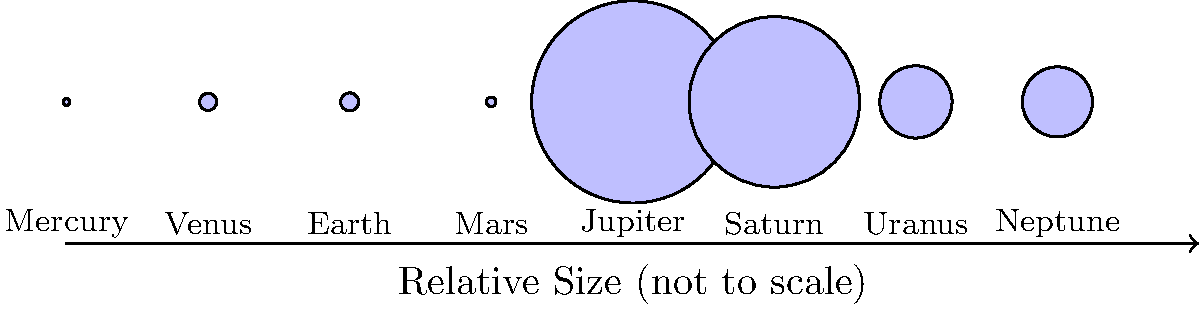In the realm of celestial bodies, where words often fall short in capturing the vastness of space, how might you describe the relative sizes of the planets in our solar system using familiar earthly objects as a metaphor? Consider Jupiter, the largest planet, as the protagonist in this cosmic narrative. To answer this question, let's approach it step-by-step, using our knowledge of relative planetary sizes and creative storytelling:

1. Jupiter is the largest planet, so we'll use it as our baseline. In the diagram, Jupiter is clearly the largest circle.

2. Relative to Jupiter:
   - Saturn is about 84% of Jupiter's size
   - Uranus and Neptune are both about 36% of Jupiter's size
   - Earth and Venus are both about 9% of Jupiter's size
   - Mars is about 5% of Jupiter's size
   - Mercury is about 3% of Jupiter's size

3. Now, let's create a metaphor using familiar objects:
   - Jupiter could be represented as a large grapefruit
   - Saturn would be a small grapefruit
   - Uranus and Neptune would be lime-sized
   - Earth and Venus would be pea-sized
   - Mars would be a peppercorn
   - Mercury would be a grain of salt

4. Crafting the narrative:
   Imagine Jupiter as a majestic grapefruit, the protagonist of our solar system's story. Its sibling Saturn, a slightly smaller grapefruit, orbits nearby. The distant cousins Uranus and Neptune roll through space like limes. Earth and Venus, though central to our tale, are mere peas in this cosmic fruit bowl. Mars, a humble peppercorn, adds spice to the narrative, while Mercury, no larger than a grain of salt, provides the first hint of flavor in our solar banquet.

This metaphor allows us to visualize the relative sizes of the planets in a way that's both imaginative and grounded in familiar objects, bridging the gap between the cosmic scale and our everyday experiences.
Answer: Jupiter as a grapefruit, Saturn a small grapefruit, Uranus and Neptune as limes, Earth and Venus as peas, Mars a peppercorn, and Mercury a grain of salt. 